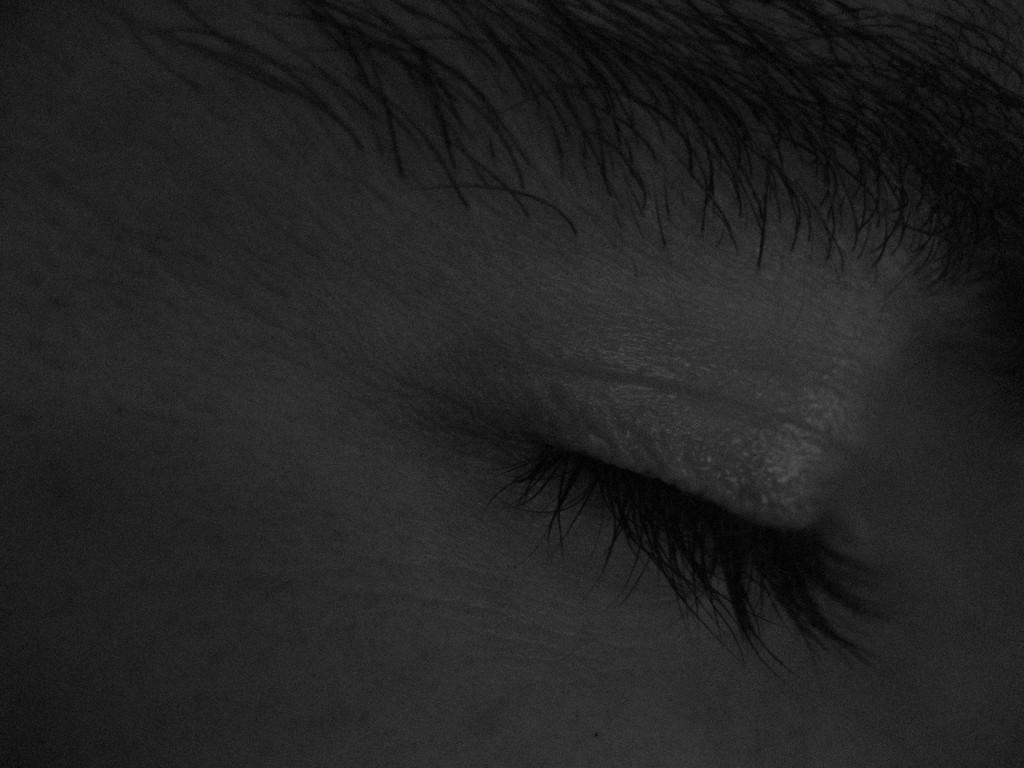What is the main subject of the image? The main subject of the image is an eye. What is located near the eye in the image? There is an eyebrow in the image. What is the eye doing in the image to show fear? The image does not depict any emotions or actions, such as fear, so it is not possible to determine what the eye might be doing in that context. 